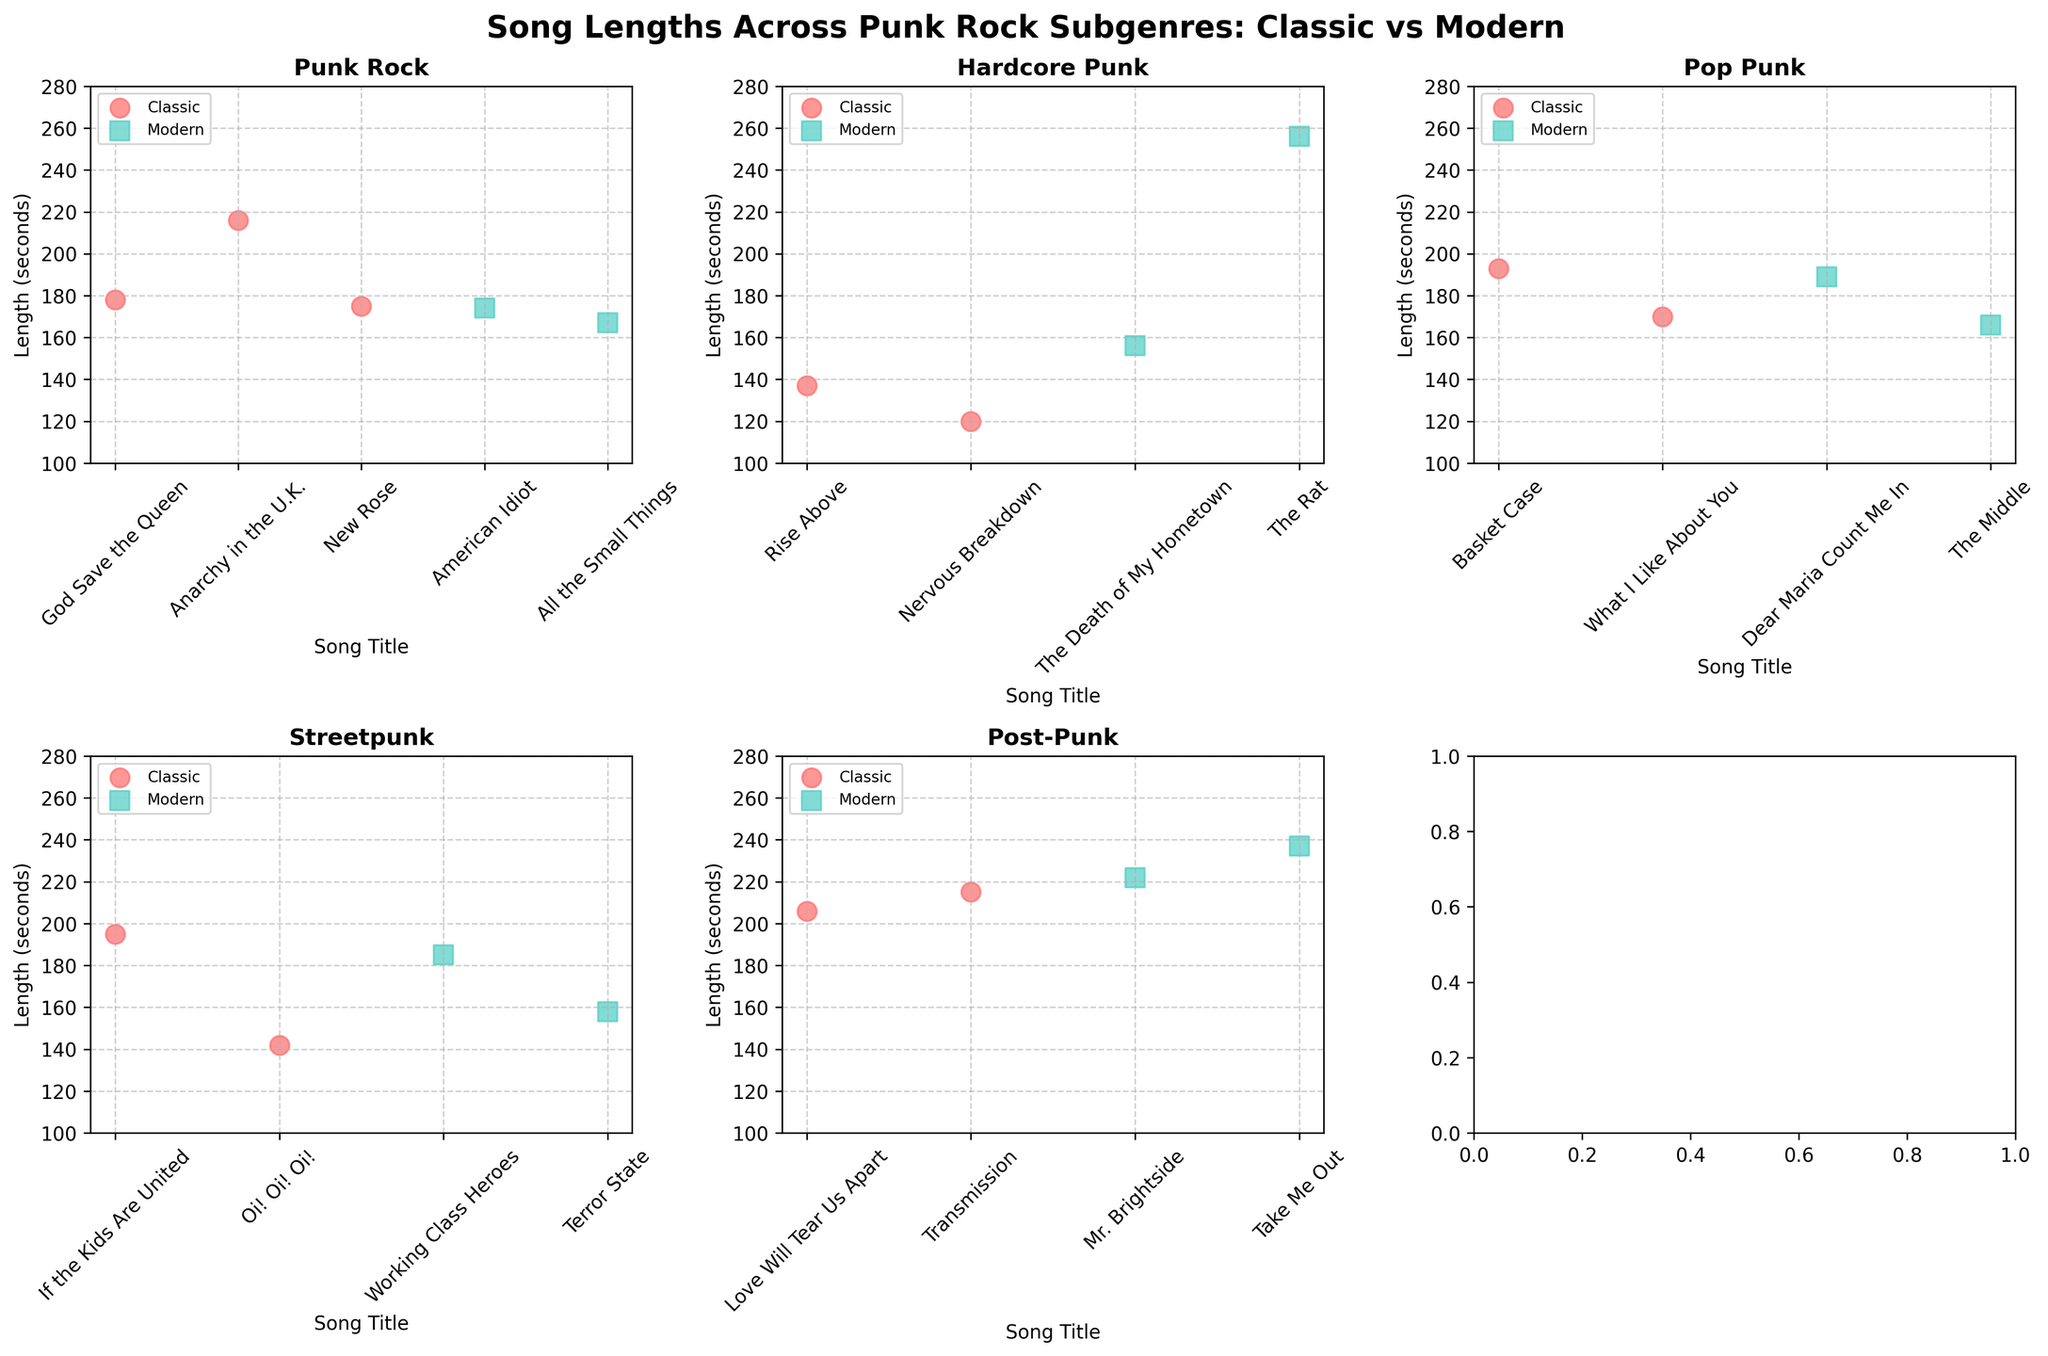How many subplots are there in the figure? There are six subgenres in the dataset, and each subgenre appears as a subplot. Therefore, counting the subgenres gives the number of subplots.
Answer: 6 Which subgenre shows the longest modern-era song in the figure? In the modern era, the longest song title and its length can be identified in the Post-Punk subplot, showing "Take Me Out" with 237 seconds.
Answer: Post-Punk What is the second shortest classic-era Hardcore Punk song length? In the Hardcore Punk classic era, the songs are "Rise Above" (137 seconds) and "Nervous Breakdown" (120 seconds). The second shortest is "Rise Above".
Answer: 137 seconds Are there any subgenres where modern-era songs are overall longer than the classic-era songs? Looking at the scatter plots, compare the length of modern-era songs to classic-era songs across each subplot. Hardcore Punk shows longer durations in the modern era compared to the classic era.
Answer: Hardcore Punk Which subgenre has the smallest range of song lengths in the classic era? Calculate the range for each subgenre in the classic era. For Punk Rock (216-175=41), Hardcore Punk (137-120=17), Pop Punk (193-170=23), Streetpunk (195-142=53), Post-Punk (215-206=9). The smallest range is in Post-Punk.
Answer: Post-Punk How does the song length distribution for Punk Rock differ between the classic and modern eras? Observe the scatter plot for Punk Rock. In the classic era, song lengths range from 175 seconds to 216 seconds, while in the modern era, lengths range from 167 seconds to 174 seconds. This shows Punk Rock songs are shorter in the modern era.
Answer: Modern era songs are shorter Which era has a higher average song length in Pop Punk? Calculate the average song length for each era in Pop Punk. For the classic era: (193+170)/2 = 181.5 seconds. For the modern era: (189+166)/2 = 177.5 seconds. The classic era has a higher average.
Answer: Classic era Are the song title ticks more crowded in any specific subgenre subplot compared to others? Analyze the x-axis ticks for each subplot. The density and spacing of song titles vary; Punk Rock might appear more crowded due to the specific layout and rotation of tick labels.
Answer: Punk Rock In which subgenre are modern era songs the most consistently close in length? Looking at the spread of the scatter plots for each subgenre in the modern era, Punk Rock songs show the most consistency as their lengths are close together (167 to 174 seconds).
Answer: Punk Rock 